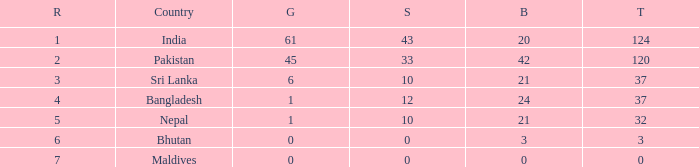Which Silver has a Rank of 6, and a Bronze smaller than 3? None. 